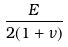<formula> <loc_0><loc_0><loc_500><loc_500>\frac { E } { 2 ( 1 + \nu ) }</formula> 